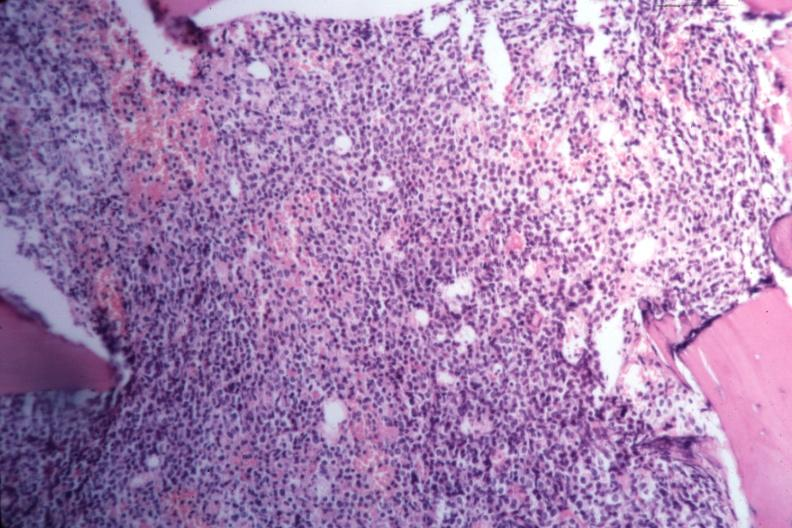what is present?
Answer the question using a single word or phrase. Bone marrow 